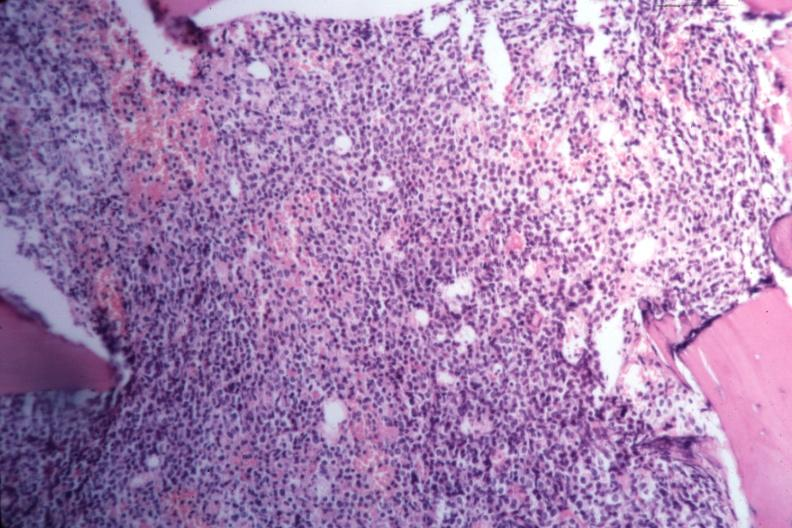what is present?
Answer the question using a single word or phrase. Bone marrow 